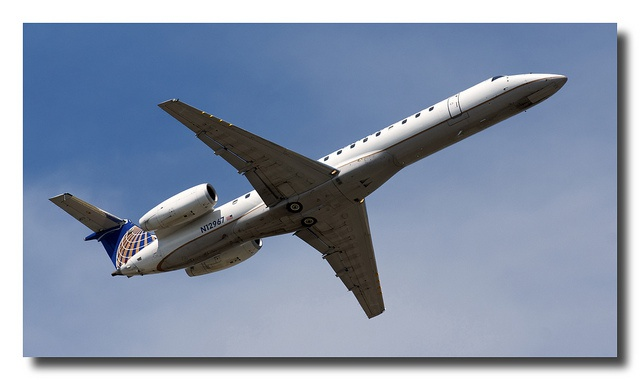Describe the objects in this image and their specific colors. I can see a airplane in white, black, lightgray, gray, and darkgray tones in this image. 